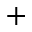Convert formula to latex. <formula><loc_0><loc_0><loc_500><loc_500>+</formula> 